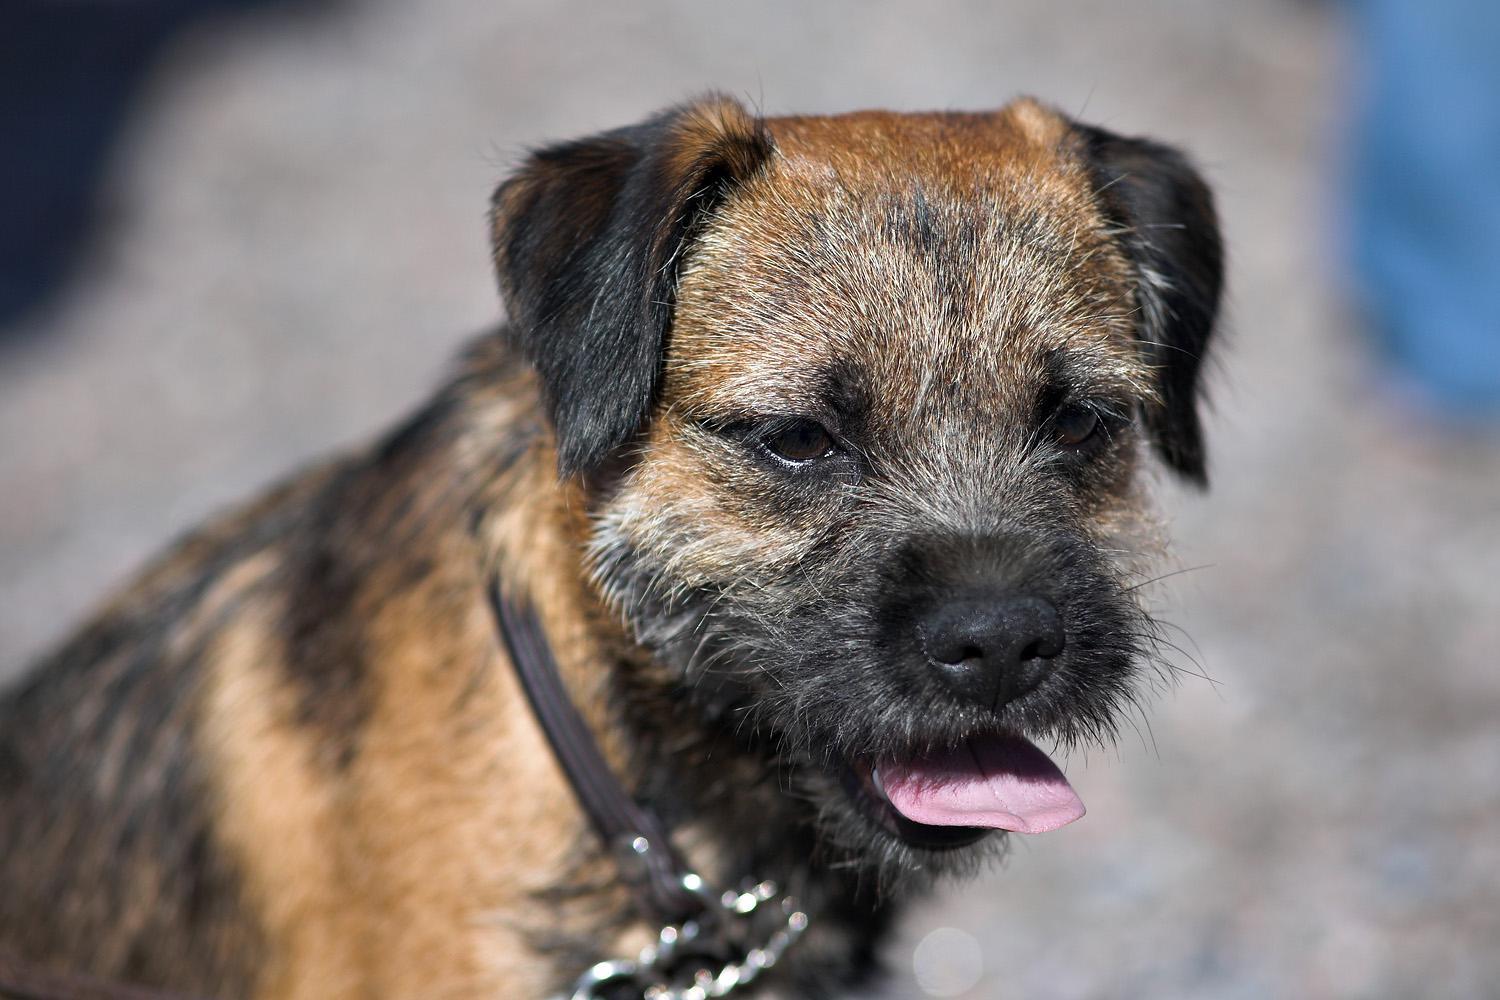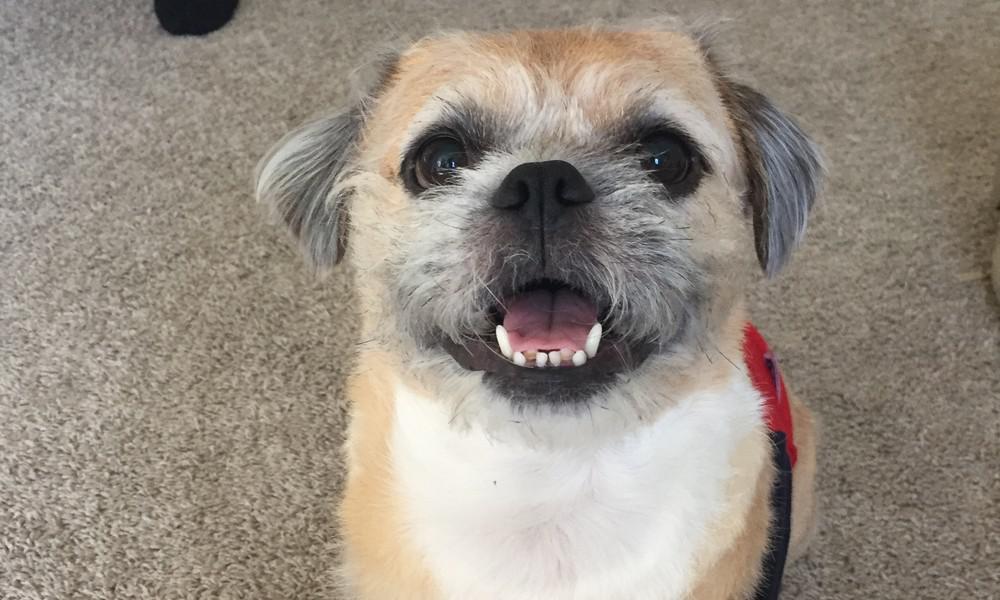The first image is the image on the left, the second image is the image on the right. Assess this claim about the two images: "Three dogs are standing in profile with their tails extended.". Correct or not? Answer yes or no. No. The first image is the image on the left, the second image is the image on the right. Given the left and right images, does the statement "At least one image shows one dog standing on grass in profile with pointing tail." hold true? Answer yes or no. No. 